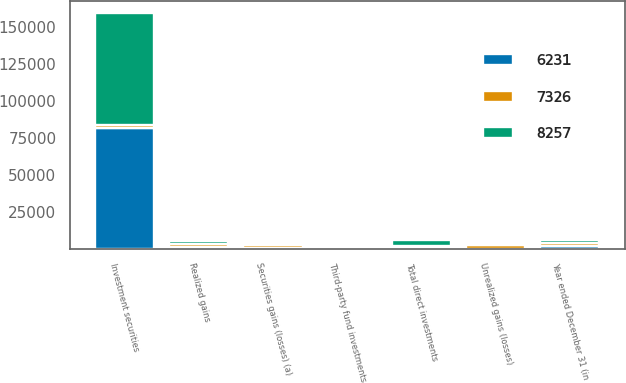<chart> <loc_0><loc_0><loc_500><loc_500><stacked_bar_chart><ecel><fcel>Year ended December 31 (in<fcel>Securities gains (losses) (a)<fcel>Investment securities<fcel>Realized gains<fcel>Unrealized gains (losses)<fcel>Total direct investments<fcel>Third-party fund investments<nl><fcel>7326<fcel>2008<fcel>1652<fcel>1717<fcel>1717<fcel>2480<fcel>763<fcel>131<nl><fcel>8257<fcel>2007<fcel>37<fcel>76200<fcel>2312<fcel>1607<fcel>3919<fcel>165<nl><fcel>6231<fcel>2006<fcel>619<fcel>82091<fcel>1223<fcel>1<fcel>1222<fcel>77<nl></chart> 